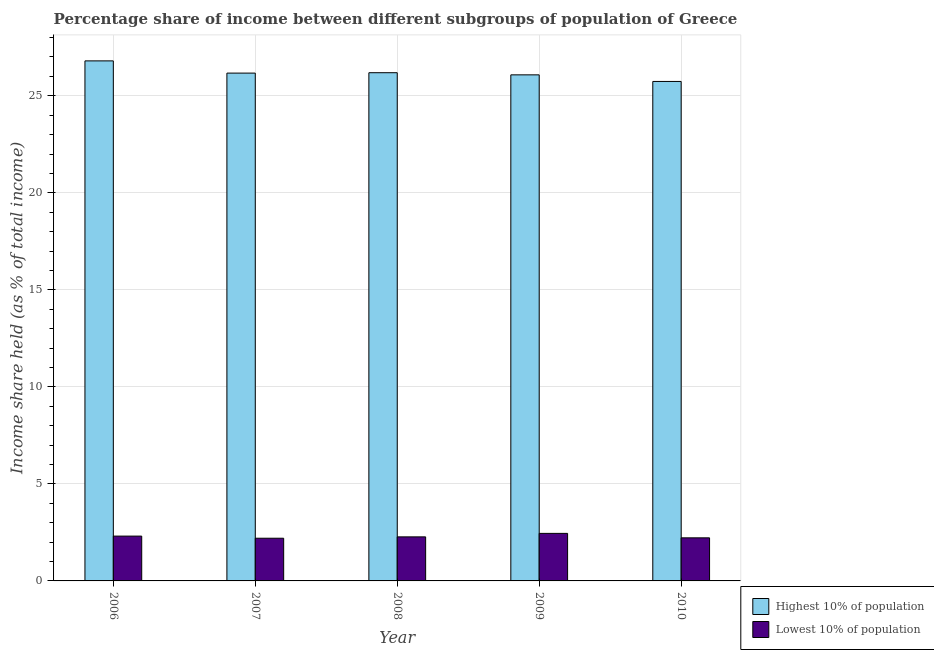How many different coloured bars are there?
Give a very brief answer. 2. Are the number of bars per tick equal to the number of legend labels?
Ensure brevity in your answer.  Yes. Are the number of bars on each tick of the X-axis equal?
Provide a succinct answer. Yes. How many bars are there on the 3rd tick from the left?
Provide a short and direct response. 2. In how many cases, is the number of bars for a given year not equal to the number of legend labels?
Keep it short and to the point. 0. What is the income share held by lowest 10% of the population in 2009?
Your answer should be compact. 2.45. Across all years, what is the maximum income share held by lowest 10% of the population?
Keep it short and to the point. 2.45. Across all years, what is the minimum income share held by highest 10% of the population?
Make the answer very short. 25.74. In which year was the income share held by highest 10% of the population maximum?
Make the answer very short. 2006. What is the total income share held by highest 10% of the population in the graph?
Provide a succinct answer. 130.98. What is the difference between the income share held by highest 10% of the population in 2009 and that in 2010?
Your answer should be very brief. 0.34. What is the difference between the income share held by lowest 10% of the population in 2008 and the income share held by highest 10% of the population in 2006?
Provide a short and direct response. -0.04. What is the average income share held by lowest 10% of the population per year?
Provide a short and direct response. 2.29. In the year 2006, what is the difference between the income share held by lowest 10% of the population and income share held by highest 10% of the population?
Your answer should be very brief. 0. What is the ratio of the income share held by highest 10% of the population in 2009 to that in 2010?
Provide a succinct answer. 1.01. What is the difference between the highest and the second highest income share held by lowest 10% of the population?
Keep it short and to the point. 0.14. In how many years, is the income share held by lowest 10% of the population greater than the average income share held by lowest 10% of the population taken over all years?
Give a very brief answer. 2. What does the 2nd bar from the left in 2010 represents?
Ensure brevity in your answer.  Lowest 10% of population. What does the 1st bar from the right in 2007 represents?
Offer a very short reply. Lowest 10% of population. How many bars are there?
Provide a succinct answer. 10. How many years are there in the graph?
Offer a very short reply. 5. Does the graph contain any zero values?
Your answer should be very brief. No. Does the graph contain grids?
Make the answer very short. Yes. Where does the legend appear in the graph?
Give a very brief answer. Bottom right. How many legend labels are there?
Keep it short and to the point. 2. What is the title of the graph?
Your answer should be compact. Percentage share of income between different subgroups of population of Greece. What is the label or title of the X-axis?
Provide a succinct answer. Year. What is the label or title of the Y-axis?
Your answer should be compact. Income share held (as % of total income). What is the Income share held (as % of total income) in Highest 10% of population in 2006?
Your answer should be compact. 26.8. What is the Income share held (as % of total income) of Lowest 10% of population in 2006?
Your answer should be very brief. 2.31. What is the Income share held (as % of total income) in Highest 10% of population in 2007?
Provide a succinct answer. 26.17. What is the Income share held (as % of total income) of Lowest 10% of population in 2007?
Your answer should be very brief. 2.2. What is the Income share held (as % of total income) in Highest 10% of population in 2008?
Give a very brief answer. 26.19. What is the Income share held (as % of total income) in Lowest 10% of population in 2008?
Give a very brief answer. 2.27. What is the Income share held (as % of total income) of Highest 10% of population in 2009?
Offer a very short reply. 26.08. What is the Income share held (as % of total income) in Lowest 10% of population in 2009?
Keep it short and to the point. 2.45. What is the Income share held (as % of total income) of Highest 10% of population in 2010?
Ensure brevity in your answer.  25.74. What is the Income share held (as % of total income) of Lowest 10% of population in 2010?
Ensure brevity in your answer.  2.22. Across all years, what is the maximum Income share held (as % of total income) in Highest 10% of population?
Keep it short and to the point. 26.8. Across all years, what is the maximum Income share held (as % of total income) of Lowest 10% of population?
Your answer should be compact. 2.45. Across all years, what is the minimum Income share held (as % of total income) of Highest 10% of population?
Keep it short and to the point. 25.74. Across all years, what is the minimum Income share held (as % of total income) of Lowest 10% of population?
Provide a short and direct response. 2.2. What is the total Income share held (as % of total income) in Highest 10% of population in the graph?
Offer a very short reply. 130.98. What is the total Income share held (as % of total income) in Lowest 10% of population in the graph?
Make the answer very short. 11.45. What is the difference between the Income share held (as % of total income) of Highest 10% of population in 2006 and that in 2007?
Ensure brevity in your answer.  0.63. What is the difference between the Income share held (as % of total income) of Lowest 10% of population in 2006 and that in 2007?
Your answer should be very brief. 0.11. What is the difference between the Income share held (as % of total income) of Highest 10% of population in 2006 and that in 2008?
Ensure brevity in your answer.  0.61. What is the difference between the Income share held (as % of total income) of Highest 10% of population in 2006 and that in 2009?
Offer a very short reply. 0.72. What is the difference between the Income share held (as % of total income) of Lowest 10% of population in 2006 and that in 2009?
Give a very brief answer. -0.14. What is the difference between the Income share held (as % of total income) in Highest 10% of population in 2006 and that in 2010?
Ensure brevity in your answer.  1.06. What is the difference between the Income share held (as % of total income) in Lowest 10% of population in 2006 and that in 2010?
Provide a short and direct response. 0.09. What is the difference between the Income share held (as % of total income) of Highest 10% of population in 2007 and that in 2008?
Your answer should be very brief. -0.02. What is the difference between the Income share held (as % of total income) of Lowest 10% of population in 2007 and that in 2008?
Make the answer very short. -0.07. What is the difference between the Income share held (as % of total income) in Highest 10% of population in 2007 and that in 2009?
Offer a terse response. 0.09. What is the difference between the Income share held (as % of total income) in Highest 10% of population in 2007 and that in 2010?
Your answer should be very brief. 0.43. What is the difference between the Income share held (as % of total income) of Lowest 10% of population in 2007 and that in 2010?
Provide a short and direct response. -0.02. What is the difference between the Income share held (as % of total income) in Highest 10% of population in 2008 and that in 2009?
Your response must be concise. 0.11. What is the difference between the Income share held (as % of total income) of Lowest 10% of population in 2008 and that in 2009?
Keep it short and to the point. -0.18. What is the difference between the Income share held (as % of total income) of Highest 10% of population in 2008 and that in 2010?
Keep it short and to the point. 0.45. What is the difference between the Income share held (as % of total income) in Lowest 10% of population in 2008 and that in 2010?
Your response must be concise. 0.05. What is the difference between the Income share held (as % of total income) of Highest 10% of population in 2009 and that in 2010?
Offer a very short reply. 0.34. What is the difference between the Income share held (as % of total income) of Lowest 10% of population in 2009 and that in 2010?
Offer a terse response. 0.23. What is the difference between the Income share held (as % of total income) in Highest 10% of population in 2006 and the Income share held (as % of total income) in Lowest 10% of population in 2007?
Provide a short and direct response. 24.6. What is the difference between the Income share held (as % of total income) of Highest 10% of population in 2006 and the Income share held (as % of total income) of Lowest 10% of population in 2008?
Ensure brevity in your answer.  24.53. What is the difference between the Income share held (as % of total income) in Highest 10% of population in 2006 and the Income share held (as % of total income) in Lowest 10% of population in 2009?
Keep it short and to the point. 24.35. What is the difference between the Income share held (as % of total income) of Highest 10% of population in 2006 and the Income share held (as % of total income) of Lowest 10% of population in 2010?
Your response must be concise. 24.58. What is the difference between the Income share held (as % of total income) of Highest 10% of population in 2007 and the Income share held (as % of total income) of Lowest 10% of population in 2008?
Provide a succinct answer. 23.9. What is the difference between the Income share held (as % of total income) of Highest 10% of population in 2007 and the Income share held (as % of total income) of Lowest 10% of population in 2009?
Make the answer very short. 23.72. What is the difference between the Income share held (as % of total income) of Highest 10% of population in 2007 and the Income share held (as % of total income) of Lowest 10% of population in 2010?
Make the answer very short. 23.95. What is the difference between the Income share held (as % of total income) of Highest 10% of population in 2008 and the Income share held (as % of total income) of Lowest 10% of population in 2009?
Your response must be concise. 23.74. What is the difference between the Income share held (as % of total income) of Highest 10% of population in 2008 and the Income share held (as % of total income) of Lowest 10% of population in 2010?
Provide a short and direct response. 23.97. What is the difference between the Income share held (as % of total income) of Highest 10% of population in 2009 and the Income share held (as % of total income) of Lowest 10% of population in 2010?
Offer a very short reply. 23.86. What is the average Income share held (as % of total income) in Highest 10% of population per year?
Provide a short and direct response. 26.2. What is the average Income share held (as % of total income) of Lowest 10% of population per year?
Offer a very short reply. 2.29. In the year 2006, what is the difference between the Income share held (as % of total income) in Highest 10% of population and Income share held (as % of total income) in Lowest 10% of population?
Make the answer very short. 24.49. In the year 2007, what is the difference between the Income share held (as % of total income) in Highest 10% of population and Income share held (as % of total income) in Lowest 10% of population?
Offer a very short reply. 23.97. In the year 2008, what is the difference between the Income share held (as % of total income) in Highest 10% of population and Income share held (as % of total income) in Lowest 10% of population?
Make the answer very short. 23.92. In the year 2009, what is the difference between the Income share held (as % of total income) of Highest 10% of population and Income share held (as % of total income) of Lowest 10% of population?
Your answer should be compact. 23.63. In the year 2010, what is the difference between the Income share held (as % of total income) of Highest 10% of population and Income share held (as % of total income) of Lowest 10% of population?
Your answer should be very brief. 23.52. What is the ratio of the Income share held (as % of total income) in Highest 10% of population in 2006 to that in 2007?
Provide a short and direct response. 1.02. What is the ratio of the Income share held (as % of total income) in Lowest 10% of population in 2006 to that in 2007?
Keep it short and to the point. 1.05. What is the ratio of the Income share held (as % of total income) in Highest 10% of population in 2006 to that in 2008?
Give a very brief answer. 1.02. What is the ratio of the Income share held (as % of total income) in Lowest 10% of population in 2006 to that in 2008?
Make the answer very short. 1.02. What is the ratio of the Income share held (as % of total income) in Highest 10% of population in 2006 to that in 2009?
Offer a terse response. 1.03. What is the ratio of the Income share held (as % of total income) in Lowest 10% of population in 2006 to that in 2009?
Your answer should be very brief. 0.94. What is the ratio of the Income share held (as % of total income) of Highest 10% of population in 2006 to that in 2010?
Offer a very short reply. 1.04. What is the ratio of the Income share held (as % of total income) of Lowest 10% of population in 2006 to that in 2010?
Offer a terse response. 1.04. What is the ratio of the Income share held (as % of total income) in Lowest 10% of population in 2007 to that in 2008?
Make the answer very short. 0.97. What is the ratio of the Income share held (as % of total income) in Highest 10% of population in 2007 to that in 2009?
Offer a very short reply. 1. What is the ratio of the Income share held (as % of total income) in Lowest 10% of population in 2007 to that in 2009?
Provide a short and direct response. 0.9. What is the ratio of the Income share held (as % of total income) of Highest 10% of population in 2007 to that in 2010?
Give a very brief answer. 1.02. What is the ratio of the Income share held (as % of total income) in Lowest 10% of population in 2007 to that in 2010?
Offer a very short reply. 0.99. What is the ratio of the Income share held (as % of total income) in Lowest 10% of population in 2008 to that in 2009?
Offer a terse response. 0.93. What is the ratio of the Income share held (as % of total income) of Highest 10% of population in 2008 to that in 2010?
Provide a short and direct response. 1.02. What is the ratio of the Income share held (as % of total income) of Lowest 10% of population in 2008 to that in 2010?
Keep it short and to the point. 1.02. What is the ratio of the Income share held (as % of total income) in Highest 10% of population in 2009 to that in 2010?
Make the answer very short. 1.01. What is the ratio of the Income share held (as % of total income) of Lowest 10% of population in 2009 to that in 2010?
Provide a short and direct response. 1.1. What is the difference between the highest and the second highest Income share held (as % of total income) in Highest 10% of population?
Make the answer very short. 0.61. What is the difference between the highest and the second highest Income share held (as % of total income) in Lowest 10% of population?
Your response must be concise. 0.14. What is the difference between the highest and the lowest Income share held (as % of total income) in Highest 10% of population?
Your response must be concise. 1.06. 